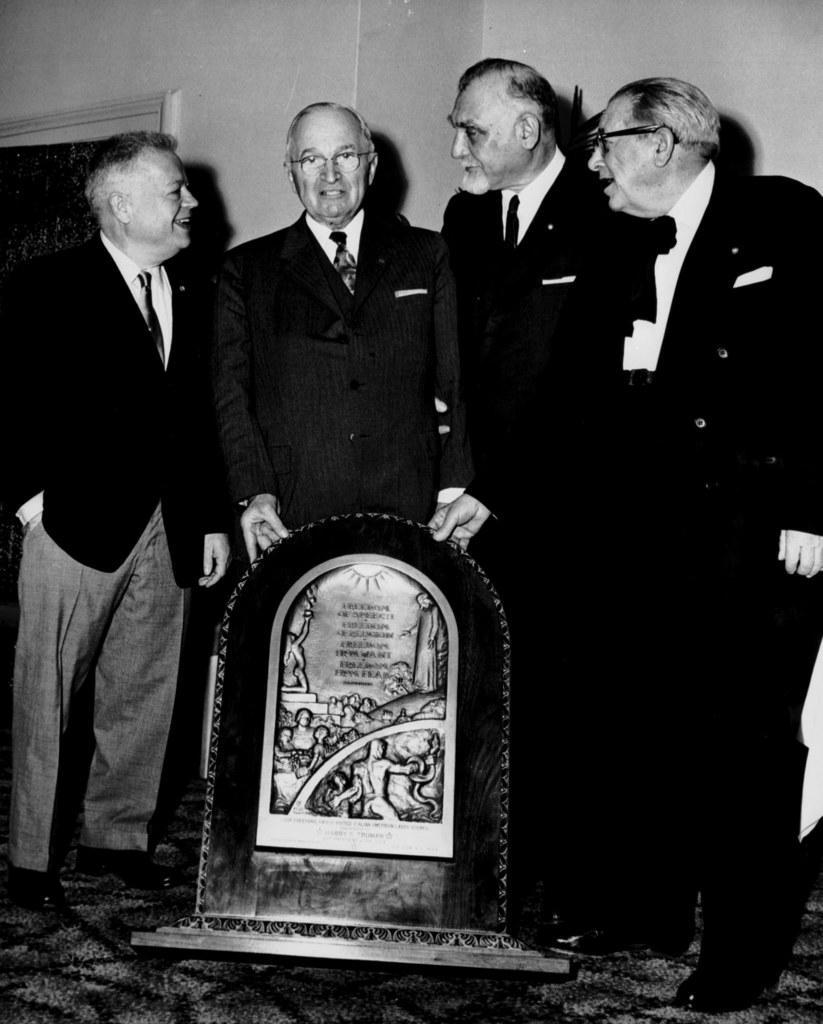Please provide a concise description of this image. This is a black and white image in this image in the center there are four people standing, and they are holding one board. On the board there is some text and some art, at the bottom there is floor and in the background there is a wall. 